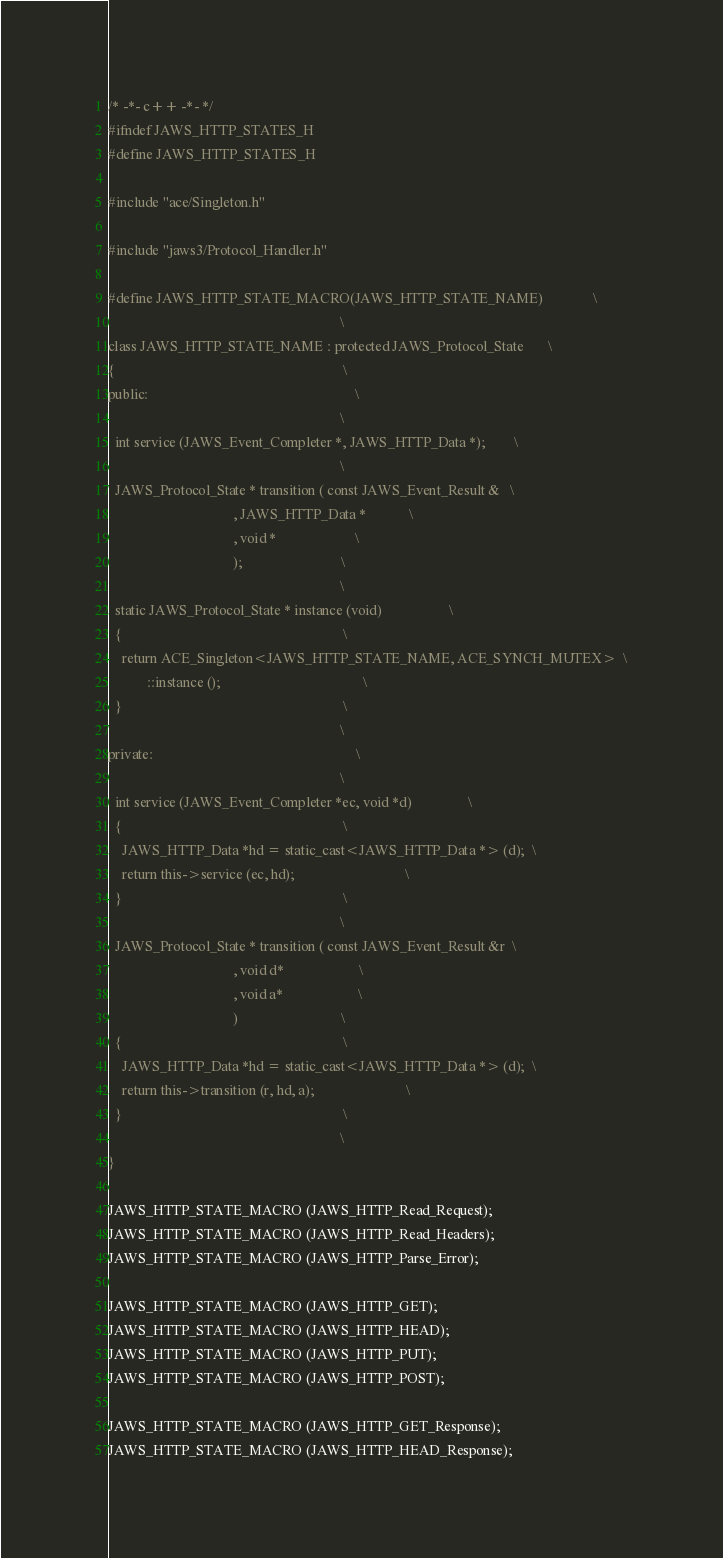<code> <loc_0><loc_0><loc_500><loc_500><_C_>/* -*- c++ -*- */
#ifndef JAWS_HTTP_STATES_H
#define JAWS_HTTP_STATES_H

#include "ace/Singleton.h"

#include "jaws3/Protocol_Handler.h"

#define JAWS_HTTP_STATE_MACRO(JAWS_HTTP_STATE_NAME)              \
                                                                 \
class JAWS_HTTP_STATE_NAME : protected JAWS_Protocol_State       \
{                                                                \
public:                                                          \
                                                                 \
  int service (JAWS_Event_Completer *, JAWS_HTTP_Data *);        \
                                                                 \
  JAWS_Protocol_State * transition ( const JAWS_Event_Result &   \
                                   , JAWS_HTTP_Data *            \
                                   , void *                      \
                                   );                            \
                                                                 \
  static JAWS_Protocol_State * instance (void)                   \
  {                                                              \
    return ACE_Singleton<JAWS_HTTP_STATE_NAME, ACE_SYNCH_MUTEX>  \
           ::instance ();                                        \
  }                                                              \
                                                                 \
private:                                                         \
                                                                 \
  int service (JAWS_Event_Completer *ec, void *d)                \
  {                                                              \
    JAWS_HTTP_Data *hd = static_cast<JAWS_HTTP_Data *> (d);  \
    return this->service (ec, hd);                               \
  }                                                              \
                                                                 \
  JAWS_Protocol_State * transition ( const JAWS_Event_Result &r  \
                                   , void d*                     \
                                   , void a*                     \
                                   )                             \
  {                                                              \
    JAWS_HTTP_Data *hd = static_cast<JAWS_HTTP_Data *> (d);  \
    return this->transition (r, hd, a);                          \
  }                                                              \
                                                                 \
}

JAWS_HTTP_STATE_MACRO (JAWS_HTTP_Read_Request);
JAWS_HTTP_STATE_MACRO (JAWS_HTTP_Read_Headers);
JAWS_HTTP_STATE_MACRO (JAWS_HTTP_Parse_Error);

JAWS_HTTP_STATE_MACRO (JAWS_HTTP_GET);
JAWS_HTTP_STATE_MACRO (JAWS_HTTP_HEAD);
JAWS_HTTP_STATE_MACRO (JAWS_HTTP_PUT);
JAWS_HTTP_STATE_MACRO (JAWS_HTTP_POST);

JAWS_HTTP_STATE_MACRO (JAWS_HTTP_GET_Response);
JAWS_HTTP_STATE_MACRO (JAWS_HTTP_HEAD_Response);</code> 